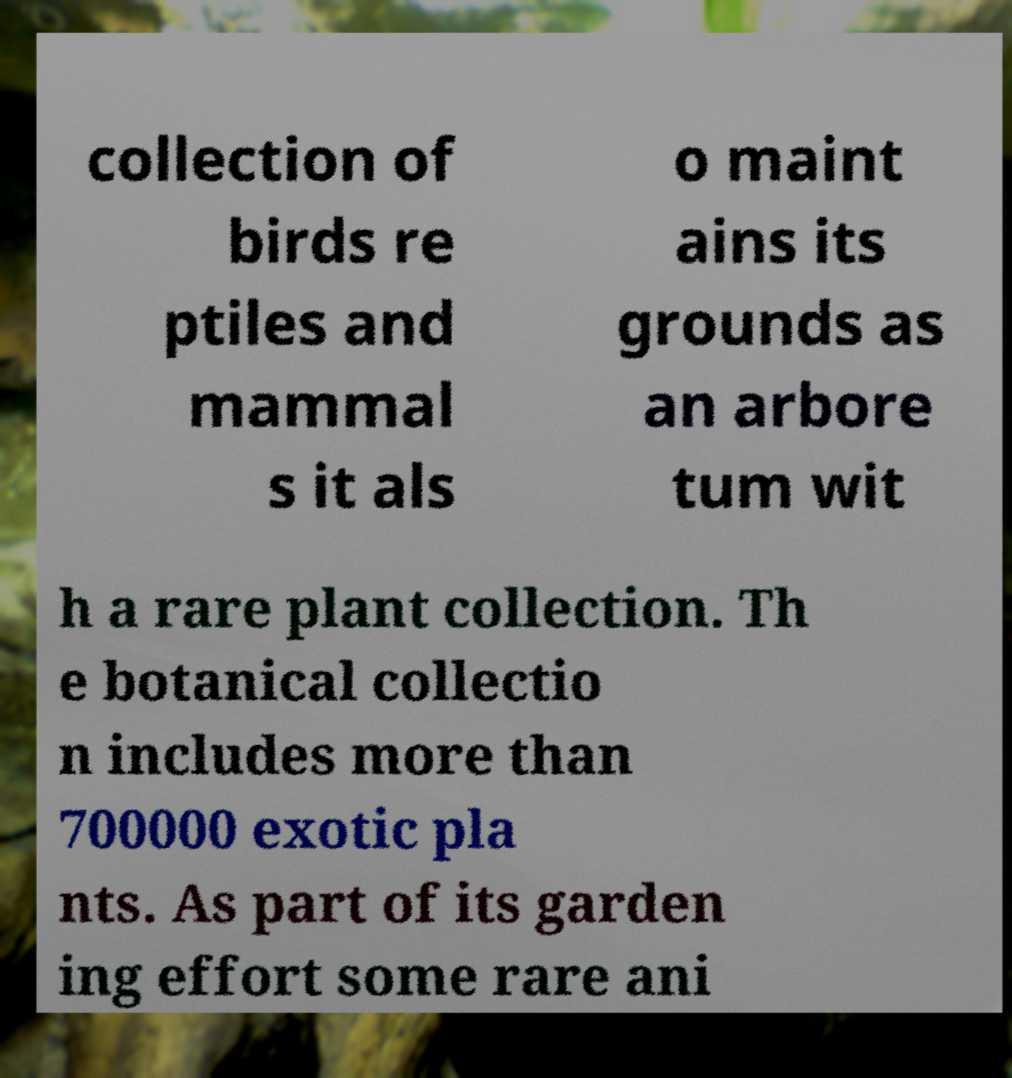Could you extract and type out the text from this image? collection of birds re ptiles and mammal s it als o maint ains its grounds as an arbore tum wit h a rare plant collection. Th e botanical collectio n includes more than 700000 exotic pla nts. As part of its garden ing effort some rare ani 